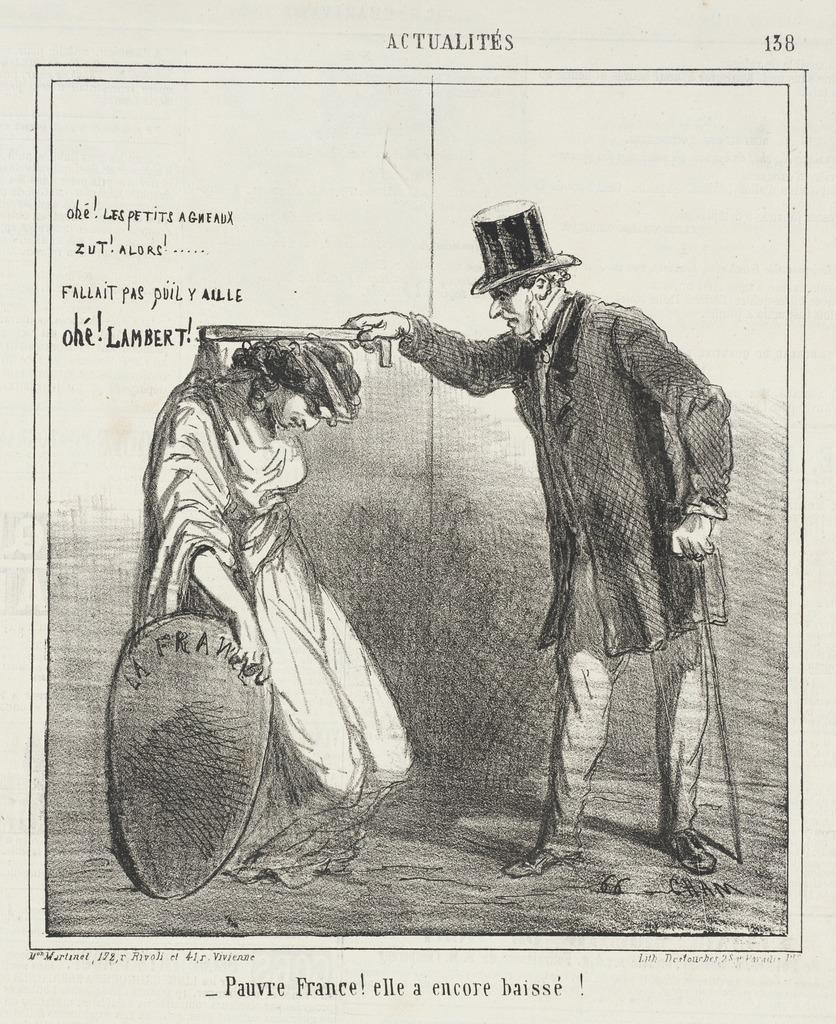How would you summarize this image in a sentence or two? In the image there is a picture of two people and some quotation is written on the left side in a page. 